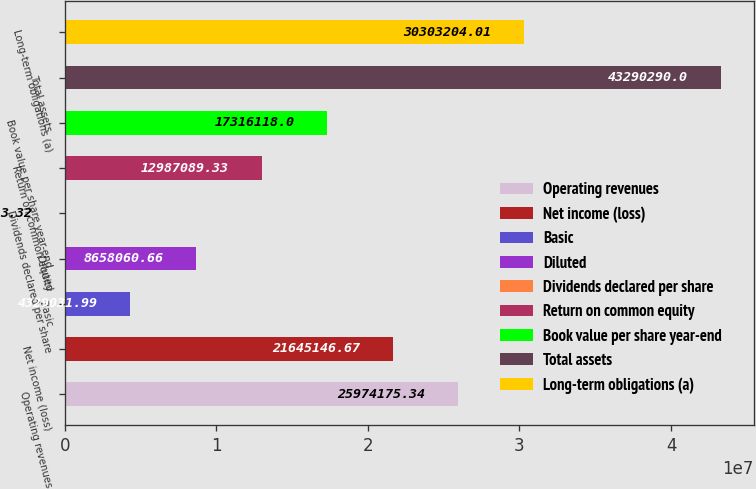Convert chart. <chart><loc_0><loc_0><loc_500><loc_500><bar_chart><fcel>Operating revenues<fcel>Net income (loss)<fcel>Basic<fcel>Diluted<fcel>Dividends declared per share<fcel>Return on common equity<fcel>Book value per share year-end<fcel>Total assets<fcel>Long-term obligations (a)<nl><fcel>2.59742e+07<fcel>2.16451e+07<fcel>4.32903e+06<fcel>8.65806e+06<fcel>3.32<fcel>1.29871e+07<fcel>1.73161e+07<fcel>4.32903e+07<fcel>3.03032e+07<nl></chart> 